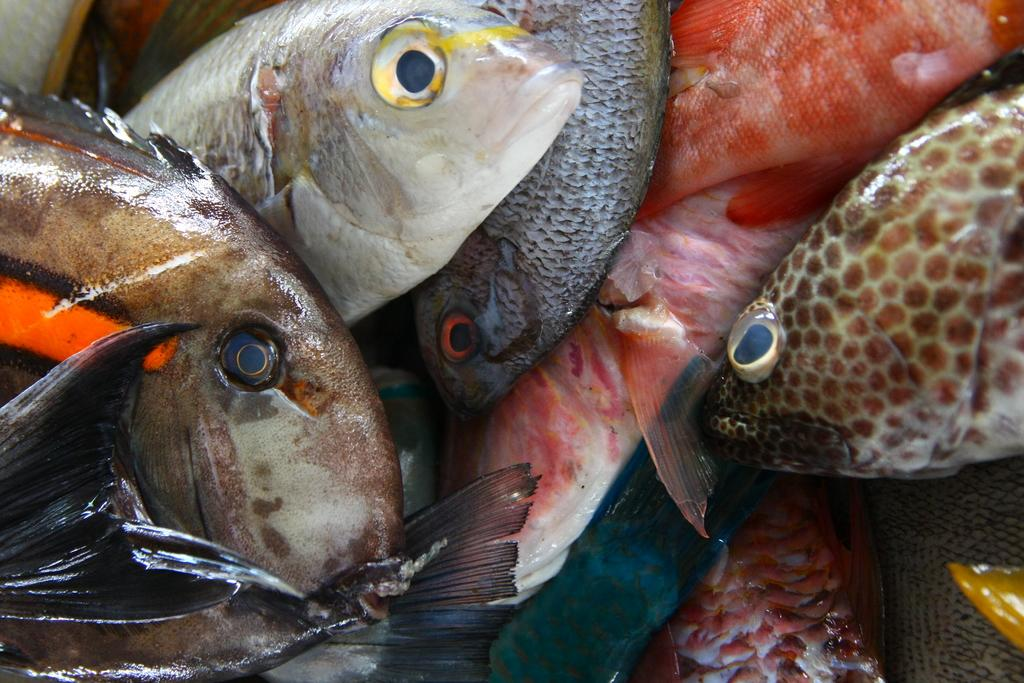What type of animals are in the image? There is a group of fishes in the image. Where are the fishes located? The fishes are in a container. What type of screw can be seen holding the container together in the image? There is no screw visible in the image; it only shows a group of fishes in a container. 